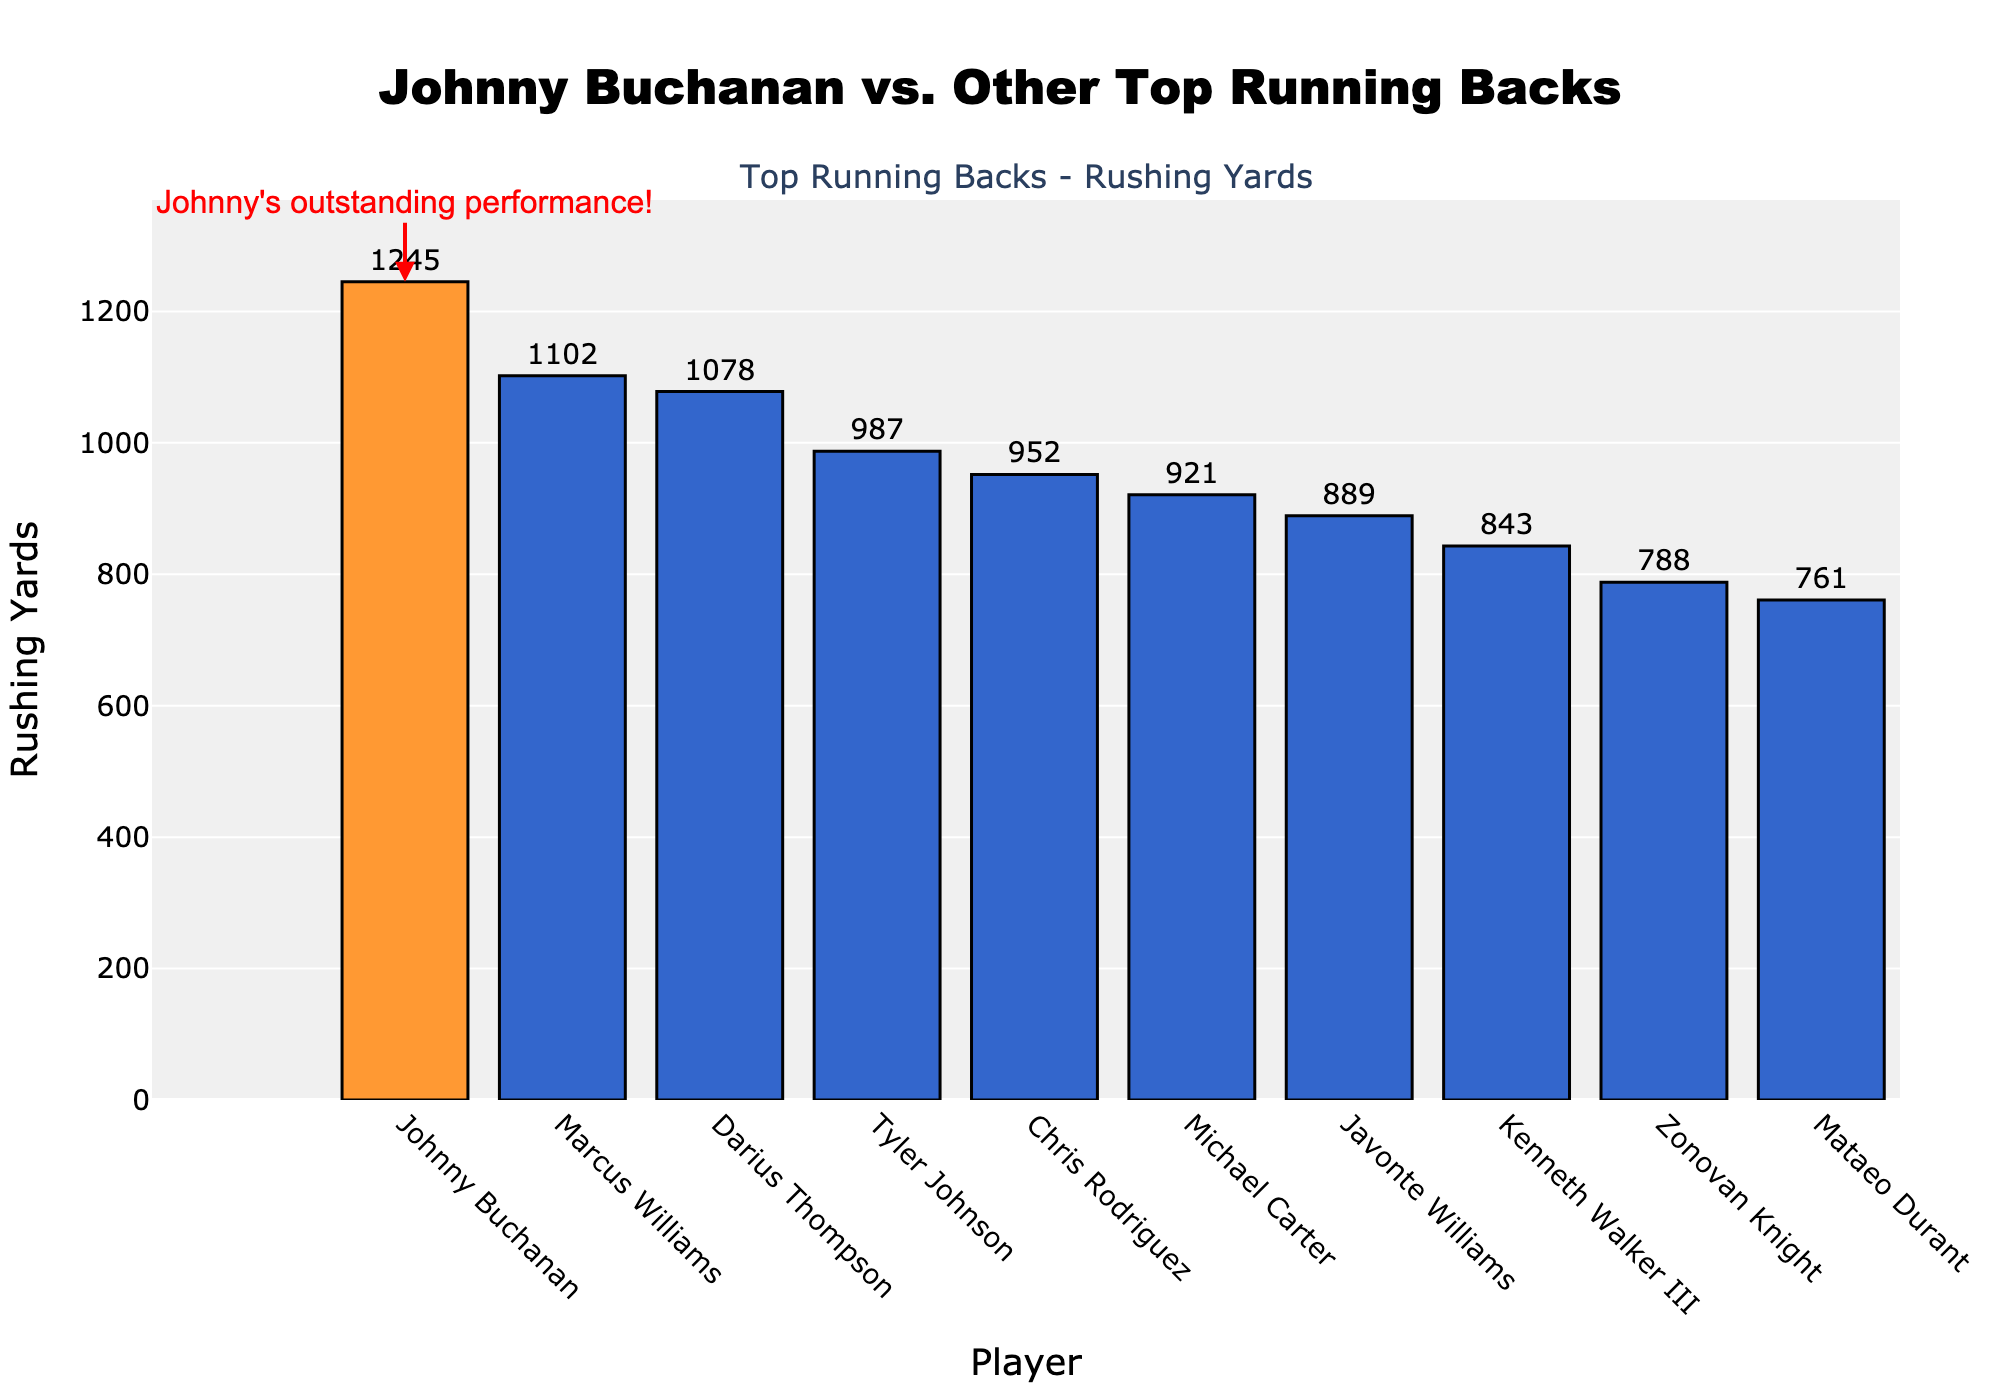Which player has the highest rushing yards? The player with the highest bar represents the highest rushing yards. Johnny Buchanan's bar is the tallest.
Answer: Johnny Buchanan By how many yards does Johnny Buchanan lead over the player with the second highest rushing yards? Johnny Buchanan has 1245 rushing yards, and Marcus Williams has 1102 rushing yards. The difference is 1245 - 1102 = 143.
Answer: 143 Which two players have the closest rushing yards? Looking at the bars with nearly the same height, Darius Thompson has 1078 yards and Tyler Johnson has 987 yards. The difference is 1078 - 987 = 91 yards.
Answer: Darius Thompson and Tyler Johnson What is the total sum of rushing yards for the three players with the least rushing yards? The three players with the shortest bars are Mataeo Durant (761), Zonovan Knight (788), and Kenneth Walker III (843). Sum: 761 + 788 + 843 = 2392.
Answer: 2392 Who ranks fifth in rushing yards, and how many yards does he have? From the sorted order, the fifth player is Chris Rodriguez with a bar indicating 952 rushing yards.
Answer: Chris Rodriguez, 952 What is the average rushing yards of the top three running backs? The top three running backs are Johnny Buchanan (1245), Marcus Williams (1102), and Darius Thompson (1078). Average: (1245 + 1102 + 1078) / 3 = 3083 / 3 = 1027.67.
Answer: 1027.67 How does Johnny Buchanan's rushing yards compare visually to Michael Carter's rushing yards? Johnny Buchanan's bar is much taller and is colored differently (orange compared to blue for others); his rushing yards (1245) are significantly higher than Michael Carter's (921).
Answer: Johnny Buchanan's bar is much taller; he has more rushing yards What's the difference in rushing yards between Javonte Williams and Kenneth Walker III? Javonte Williams has 889 rushing yards, and Kenneth Walker III has 843 rushing yards. The difference is 889 - 843 = 46.
Answer: 46 Which player has just below 1000 rushing yards? Tyler Johnson, with a bar slightly below the 1000-yard mark, has 987 rushing yards.
Answer: Tyler Johnson By how many yards does Chris Rodriguez exceed Mataeo Durant? Chris Rodriguez has 952 rushing yards, while Mataeo Durant has 761. The difference is 952 - 761 = 191.
Answer: 191 